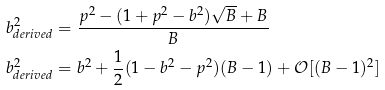<formula> <loc_0><loc_0><loc_500><loc_500>b _ { d e r i v e d } ^ { 2 } & = \frac { p ^ { 2 } - ( 1 + p ^ { 2 } - b ^ { 2 } ) \sqrt { B } + B } { B } \\ b _ { d e r i v e d } ^ { 2 } & = b ^ { 2 } + \frac { 1 } { 2 } ( 1 - b ^ { 2 } - p ^ { 2 } ) ( B - 1 ) + \mathcal { O } [ ( B - 1 ) ^ { 2 } ]</formula> 